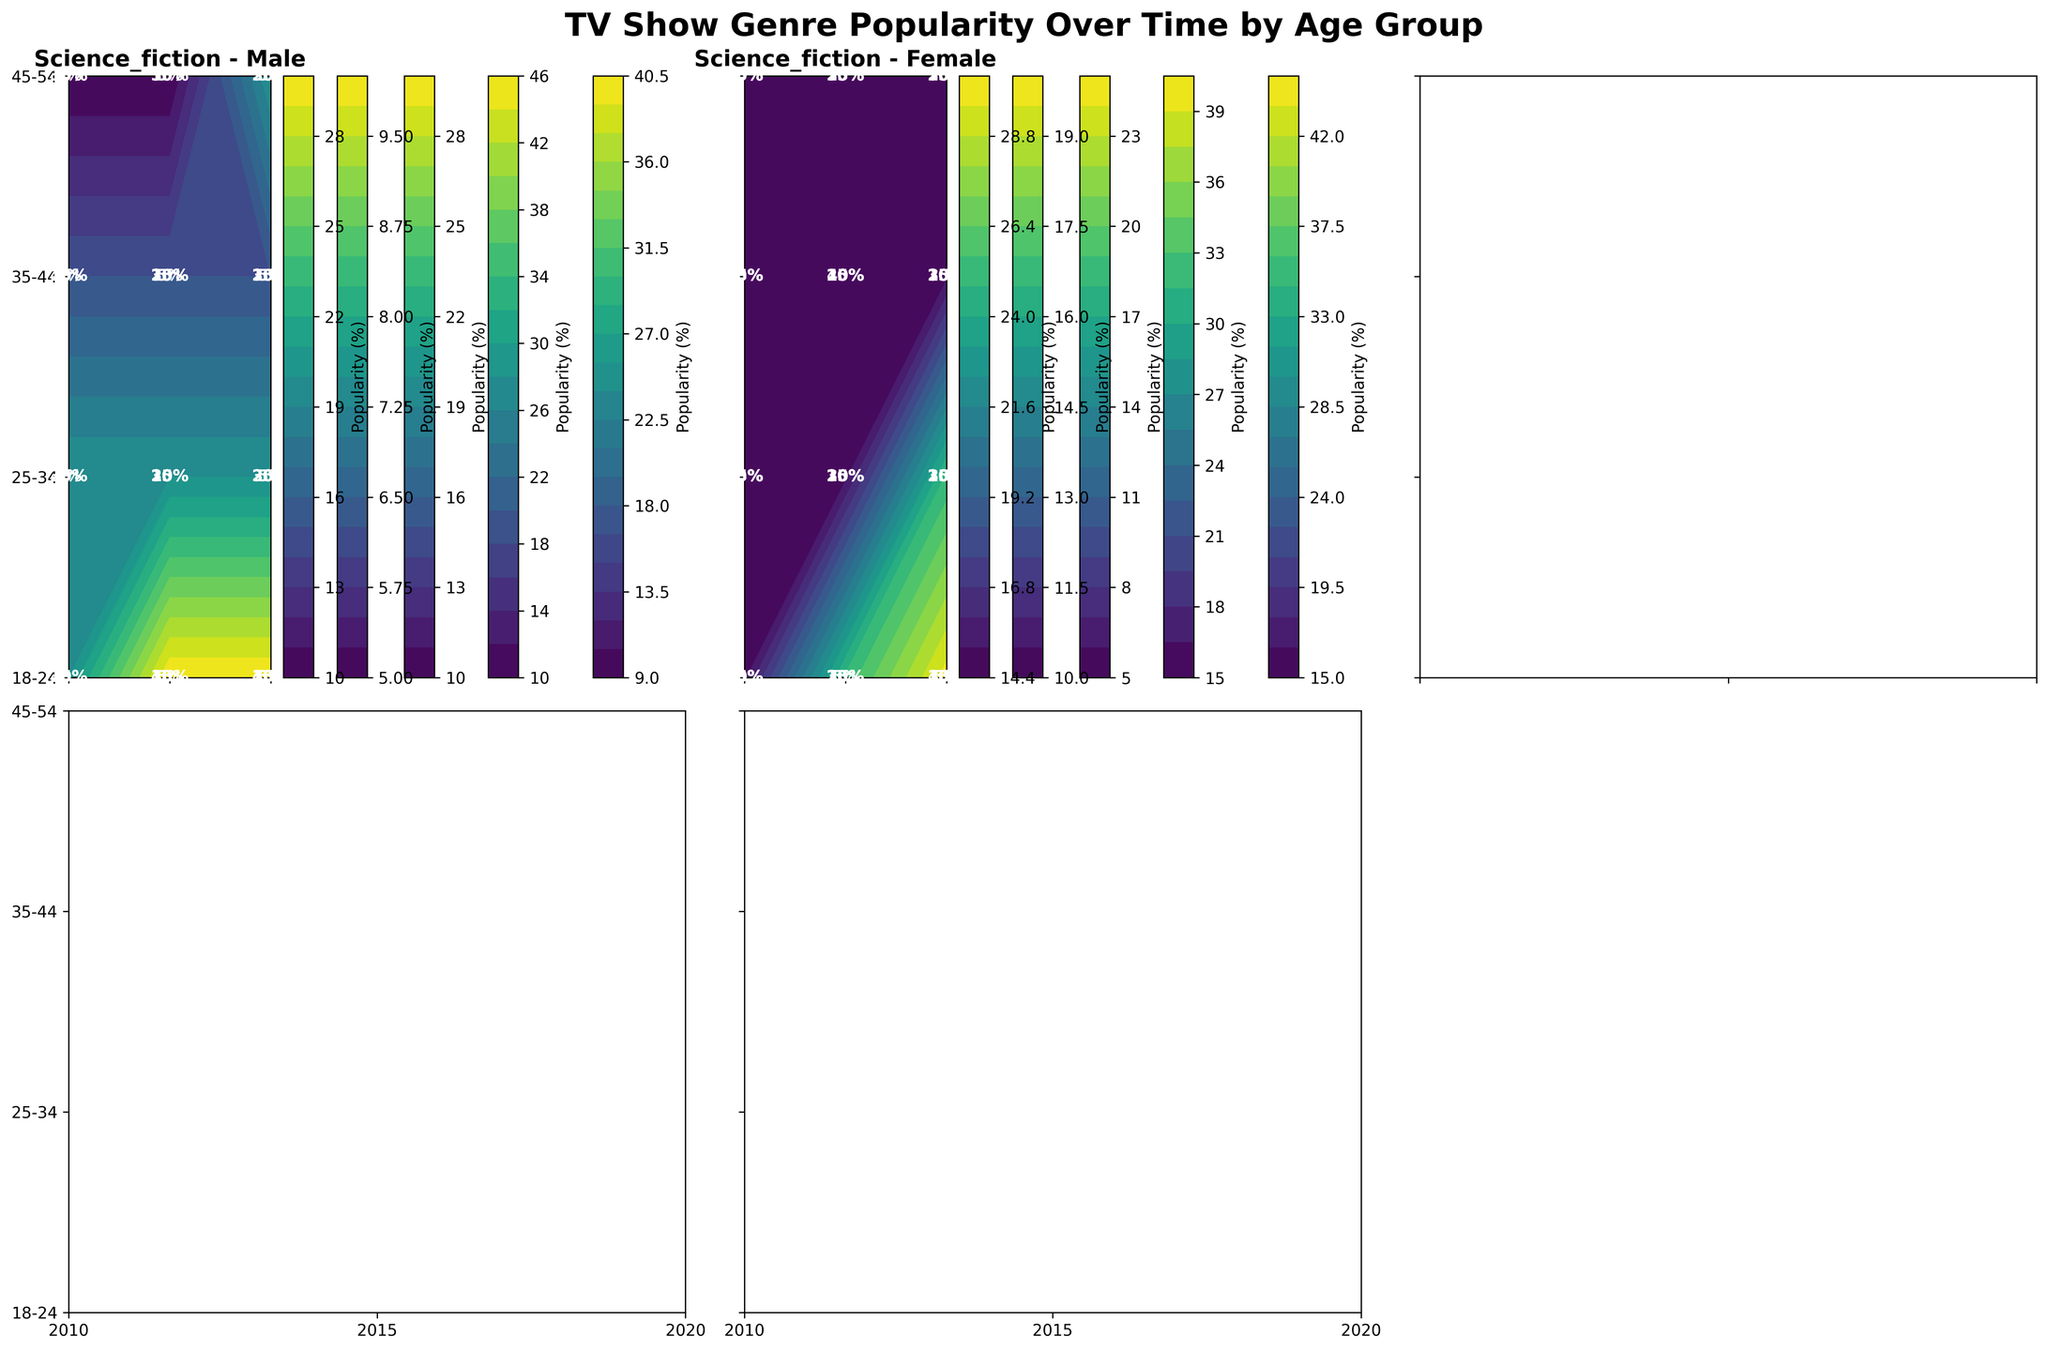what's the highest popularity percentage for dramas among males in 2020? Locate the contour plot for males, find the age group with the highest value for dramas in 2020, and note the value shown.
Answer: 30 which age group saw the highest increase in popularity for comedies from 2010 to 2020 for males? Check the contour plots for males and compare the popularity percentages for comedies in each age group from 2010 to 2020 to identify the highest increase.
Answer: 18-24 between males and females in 2015, who had a higher interest in reality TV shows for the 25-34 age group? Compare the contour plots for males and females in 2015 for the 25-34 age group and identify the higher value for reality TV shows.
Answer: Females how did the popularity of science fiction among females aged 18-24 change from 2010 to 2020? Observe the values for science fiction in the contour plot for females aged 18-24 and note the change from 2010 to 2020.
Answer: Increased for thrillers in 2020, which gender and age group had the highest popularity percentage? Look at the contour plots for thrillers in 2020 and identify the highest value for both genders across all age groups.
Answer: Males 45-54 which genre showed the most consistent popularity change for females across the age groups from 2010 to 2020? Review the contour plots for each genre among females and compare the popularity patterns across ages from 2010 to 2020 to find the most consistent change.
Answer: Science fiction was there a significant drop in drama popularity for any male age group between 2010 and 2020? Check the contour plots for drama among males and compare the popularity percentages from 2010 to 2020 for any noticeable drop.
Answer: Yes, 18-24 did females aged 35-44 display any significant trends in the popularity of reality TV from 2010 to 2020? Observe the values for reality TV in the contour plot for females aged 35-44 from 2010 to 2020 to see if any significant trends appear.
Answer: No significant trends for the 18-24 age group in 2015, which genre saw the largest disparity in popularity between males and females? Compare the contour plots for both genders in 2015 for the 18-24 age group and identify the genre with the largest difference in percentages.
Answer: Comedy 